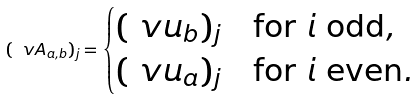Convert formula to latex. <formula><loc_0><loc_0><loc_500><loc_500>( \ v A _ { a , b } ) _ { j } = \begin{cases} ( \ v u _ { b } ) _ { j } & \text {for $i$ odd} , \\ ( \ v u _ { a } ) _ { j } & \text {for $i$ even} . \end{cases}</formula> 